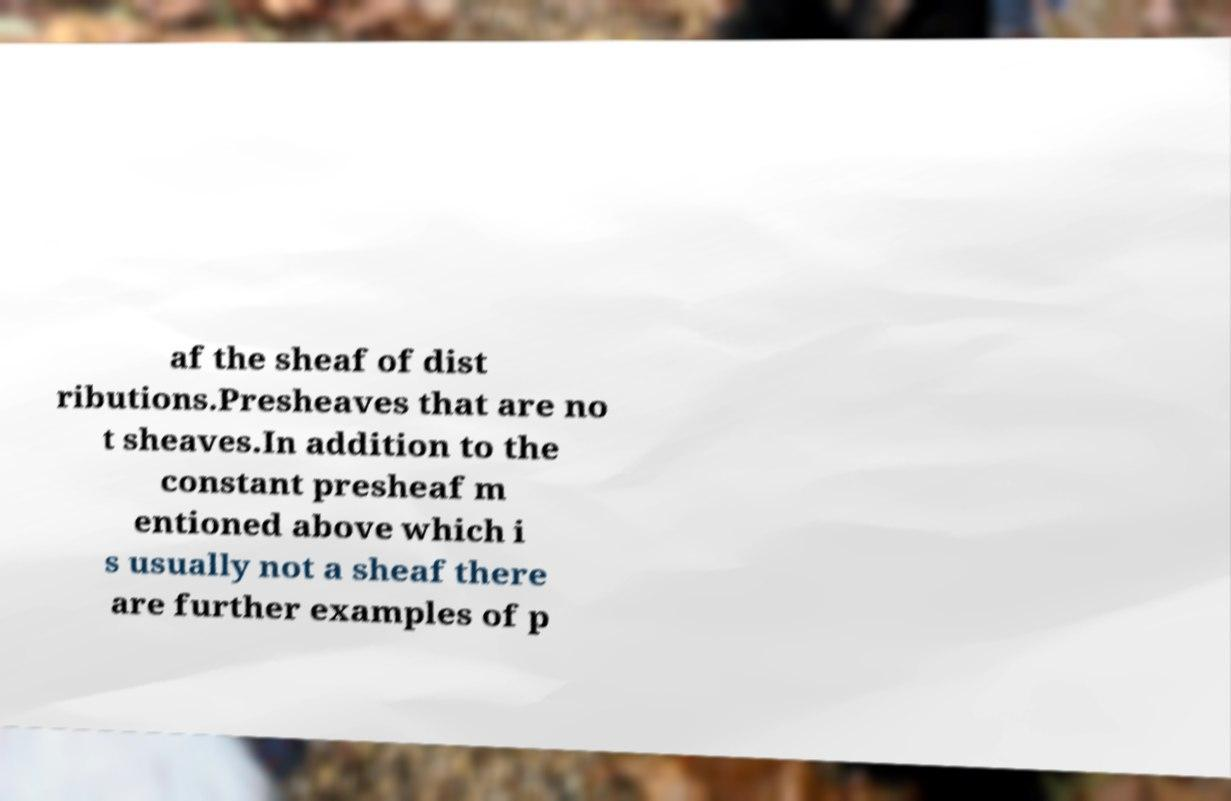Can you accurately transcribe the text from the provided image for me? af the sheaf of dist ributions.Presheaves that are no t sheaves.In addition to the constant presheaf m entioned above which i s usually not a sheaf there are further examples of p 